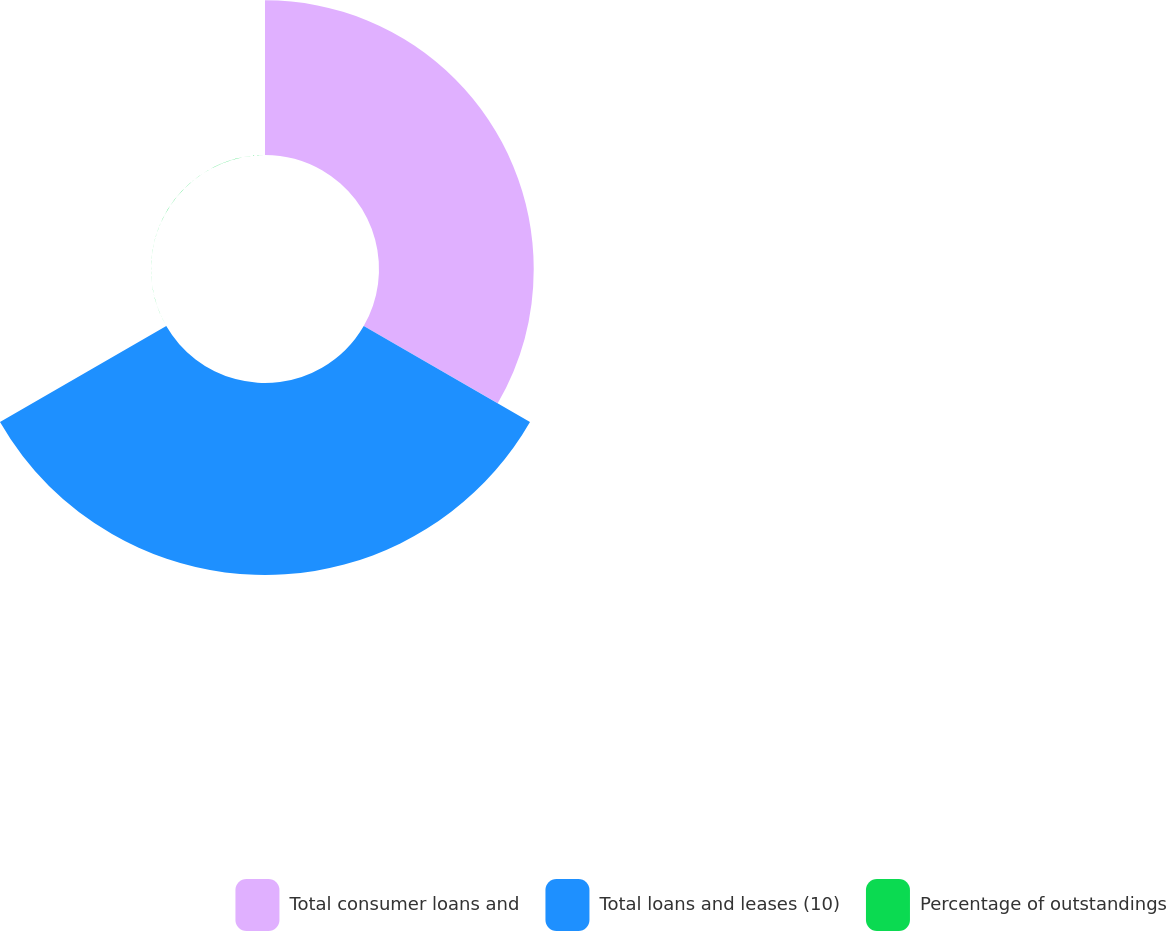Convert chart to OTSL. <chart><loc_0><loc_0><loc_500><loc_500><pie_chart><fcel>Total consumer loans and<fcel>Total loans and leases (10)<fcel>Percentage of outstandings<nl><fcel>44.62%<fcel>55.37%<fcel>0.01%<nl></chart> 